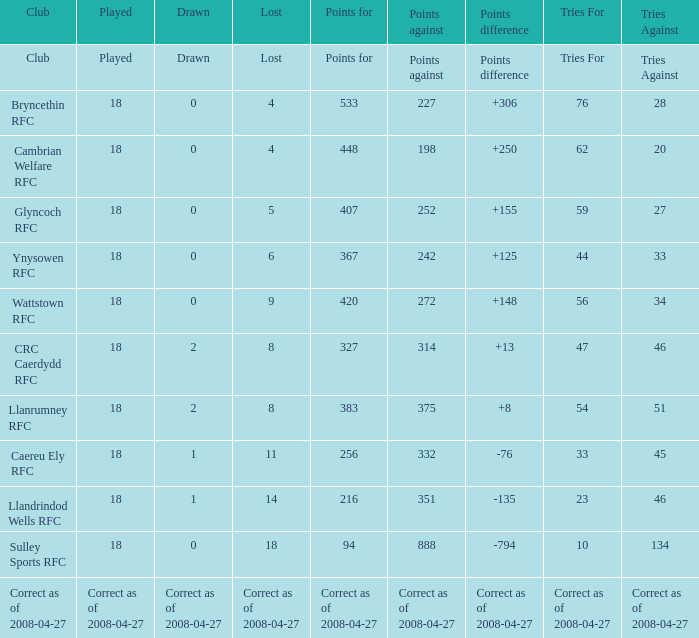What is the amount for the object "lost" when the number "tries" equals 47? 8.0. 